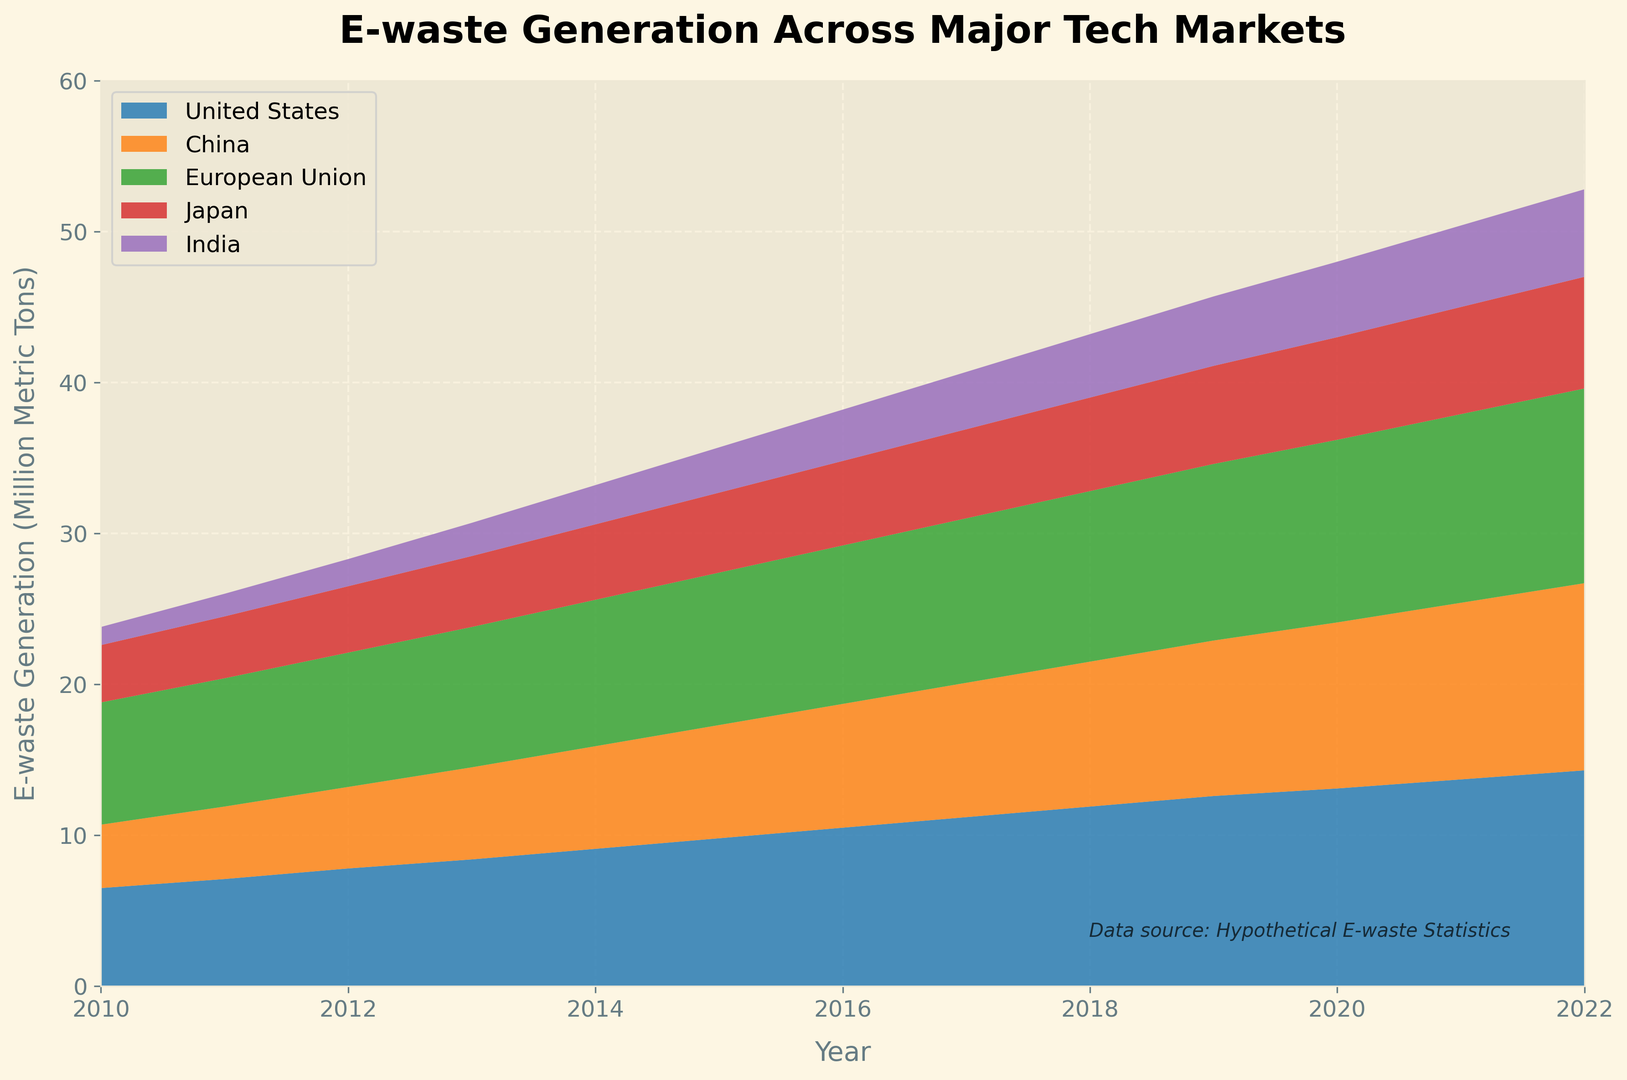What is the total e-waste generation for the United States from 2010 to 2022? Sum up all the values for the United States from 2010 to 2022: 6.5 + 7.1 + 7.8 + 8.4 + 9.1 + 9.8 + 10.5 + 11.2 + 11.9 + 12.6 + 13.1 + 13.7 + 14.3 = 135
Answer: 135 Which country showed the highest increase in e-waste generation over the period 2010 to 2022? Calculate the difference between the values in 2022 and 2010 for each country:
- United States: 14.3 - 6.5 = 7.8
- China: 12.4 - 4.2 = 8.2
- European Union: 12.9 - 8.1 = 4.8
- Japan: 7.4 - 3.8 = 3.6
- India: 5.8 - 1.2 = 4.6 
China has the highest increase of 8.2
Answer: China What was the average e-waste generation for India during the period 2010 to 2022? Sum up the e-waste generation values for India from 2010 to 2022 and divide by the number of years: (1.2 + 1.5 + 1.8 + 2.2 + 2.6 + 3.0 + 3.4 + 3.8 + 4.2 + 4.6 + 5.0 + 5.4 + 5.8) / 13 = 44.5 / 13 ≈ 3.42
Answer: 3.42 In which year did the European Union generate the most e-waste, and how much was it? Check the values for each year and find the maximum for the European Union: The highest value is 12.9 million metric tons in the year 2022
Answer: 2022, 12.9 million metric tons Between the United States and India, which country had a higher e-waste generation in 2014 and by how much? US in 2014: 9.1, India in 2014: 2.6. Difference: 9.1 - 2.6 = 6.5
Answer: United States, 6.5 Which country had the earliest peak in e-waste generation, and in which year did it occur? Identify the year each country reached their highest value:
- United States: 14.3 in 2022
- China: 12.4 in 2022
- European Union: 12.9 in 2022
- Japan: 7.4 in 2022
- India: 5.8 in 2022
Since all countries have their peak in 2022, the question should be revised to look for the highest value up to 2021.
Answer: All countries peaked in 2022 What was the cumulative e-waste generation for all countries in the year 2020? Sum the values for all countries in 2020: 13.1 + 11.0 + 12.1 + 6.8 + 5.0 = 48
Answer: 48 From 2010 to 2022, which country had the smallest increase in e-waste generation, and what was the amount of increase? Calculate the difference between 2022 and 2010 values for each country:
- United States: 14.3 - 6.5 = 7.8
- China: 12.4 - 4.2 = 8.2
- European Union: 12.9 - 8.1 = 4.8
- Japan: 7.4 - 3.8 = 3.6
- India: 5.8 - 1.2 = 4.6 
Japan has the smallest increase of 3.6
Answer: Japan, 3.6 Compare the e-waste generation of China and the European Union in 2013. Which one is higher, and what is the difference? China in 2013: 6.1, European Union in 2013: 9.3. Difference: 9.3 - 6.1 = 3.2
Answer: European Union, 3.2 How does the trend in e-waste generation for Japan compare to that of India? Examine the general trend of the data points from 2010 to 2022. Both countries show an increasing trend, but Japan’s increase is more gradual compared to India's steeper rise after 2013.
Answer: Gradual (Japan), Steeper (India) 